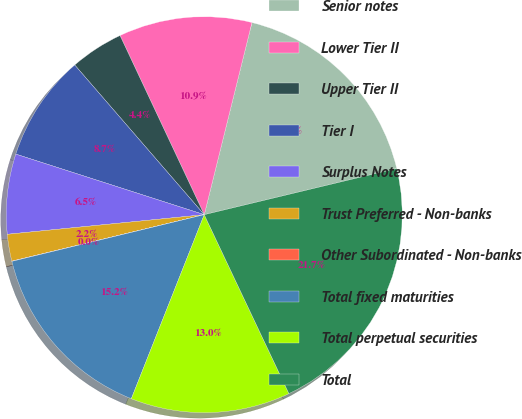Convert chart. <chart><loc_0><loc_0><loc_500><loc_500><pie_chart><fcel>Senior notes<fcel>Lower Tier II<fcel>Upper Tier II<fcel>Tier I<fcel>Surplus Notes<fcel>Trust Preferred - Non-banks<fcel>Other Subordinated - Non-banks<fcel>Total fixed maturities<fcel>Total perpetual securities<fcel>Total<nl><fcel>17.38%<fcel>10.87%<fcel>4.36%<fcel>8.7%<fcel>6.53%<fcel>2.19%<fcel>0.02%<fcel>15.21%<fcel>13.04%<fcel>21.72%<nl></chart> 